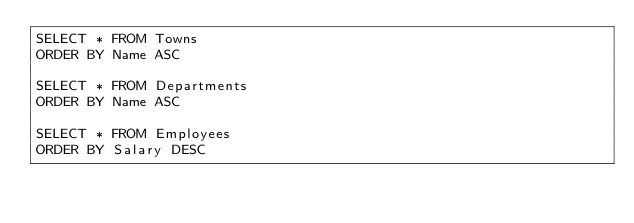Convert code to text. <code><loc_0><loc_0><loc_500><loc_500><_SQL_>SELECT * FROM Towns
ORDER BY Name ASC

SELECT * FROM Departments 
ORDER BY Name ASC

SELECT * FROM Employees 
ORDER BY Salary DESC</code> 